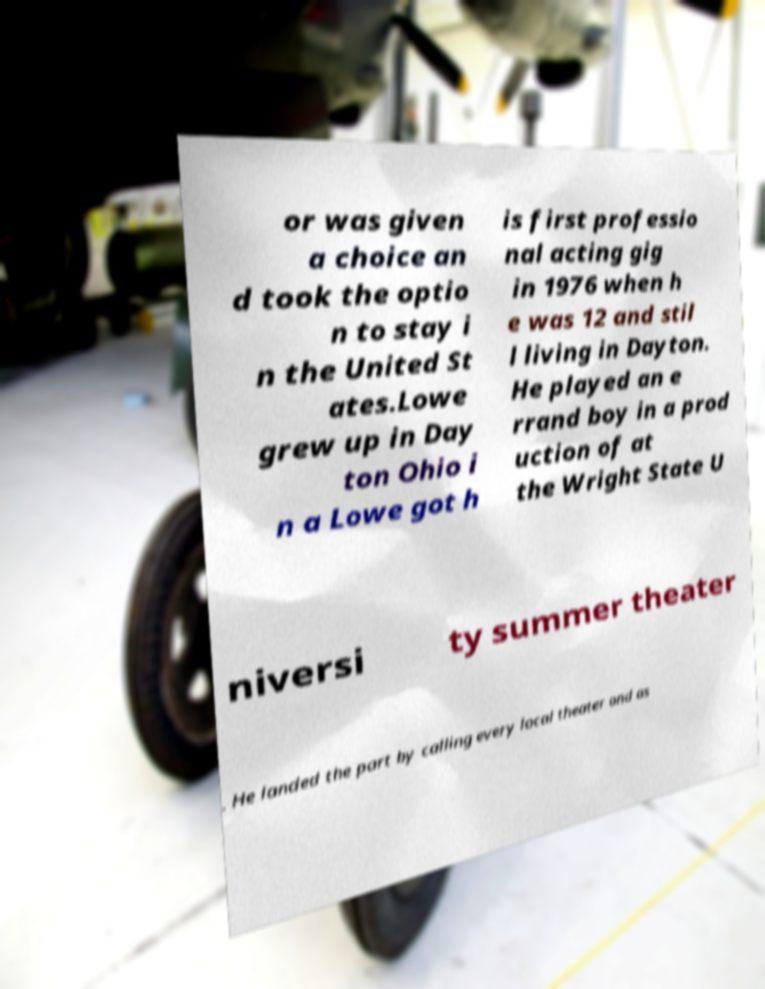For documentation purposes, I need the text within this image transcribed. Could you provide that? or was given a choice an d took the optio n to stay i n the United St ates.Lowe grew up in Day ton Ohio i n a Lowe got h is first professio nal acting gig in 1976 when h e was 12 and stil l living in Dayton. He played an e rrand boy in a prod uction of at the Wright State U niversi ty summer theater . He landed the part by calling every local theater and as 